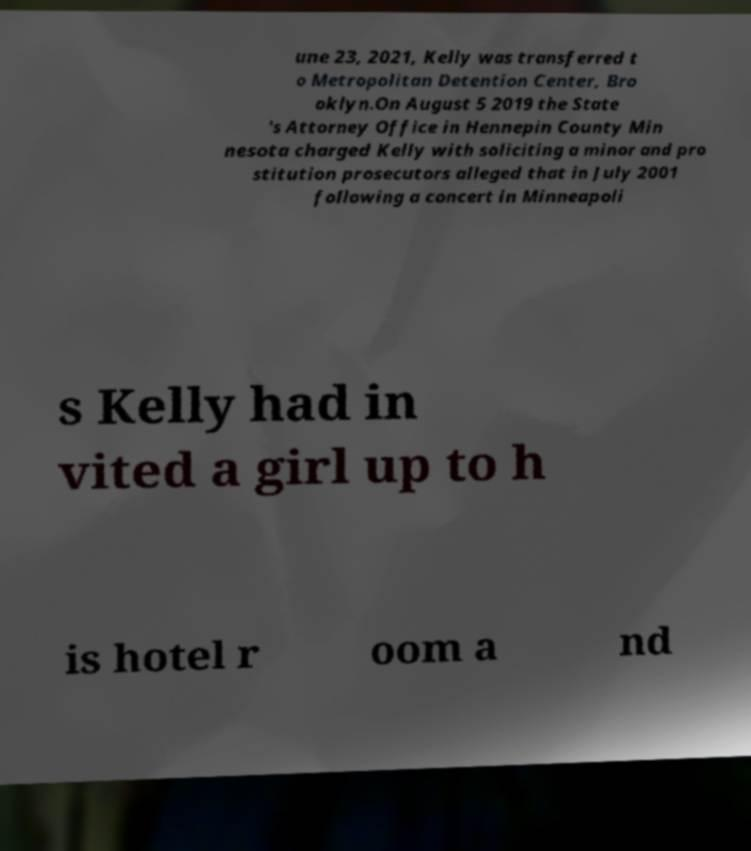Please read and relay the text visible in this image. What does it say? une 23, 2021, Kelly was transferred t o Metropolitan Detention Center, Bro oklyn.On August 5 2019 the State 's Attorney Office in Hennepin County Min nesota charged Kelly with soliciting a minor and pro stitution prosecutors alleged that in July 2001 following a concert in Minneapoli s Kelly had in vited a girl up to h is hotel r oom a nd 